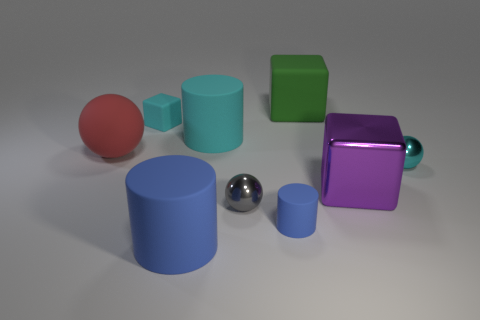Subtract all balls. How many objects are left? 6 Subtract all big gray balls. Subtract all metal cubes. How many objects are left? 8 Add 1 shiny objects. How many shiny objects are left? 4 Add 8 tiny blue rubber balls. How many tiny blue rubber balls exist? 8 Subtract 0 purple balls. How many objects are left? 9 